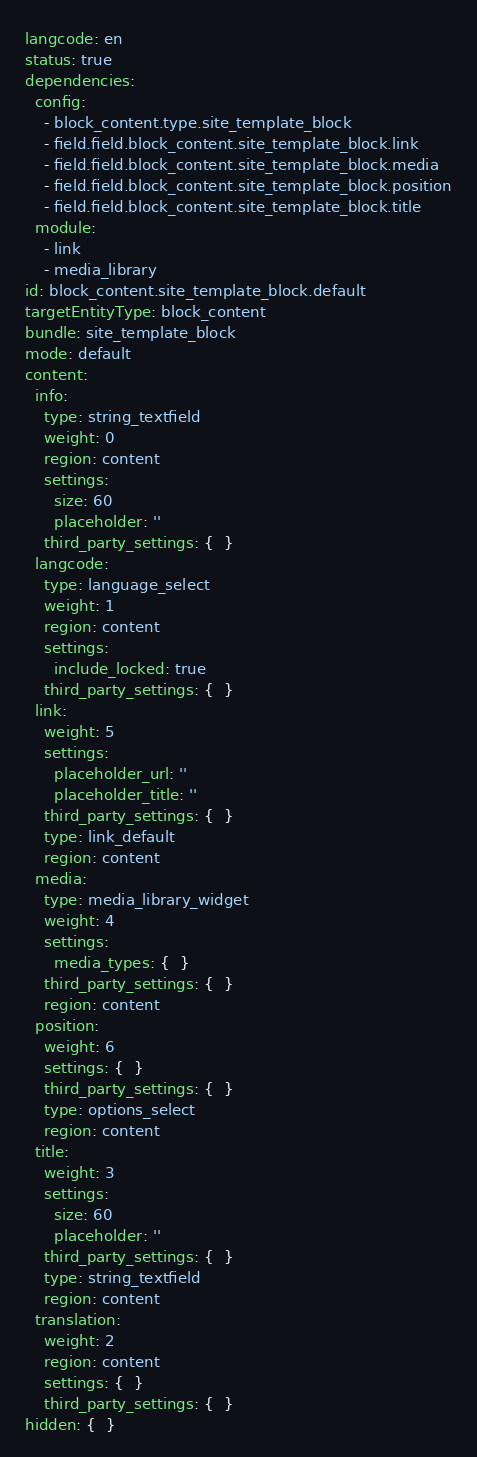Convert code to text. <code><loc_0><loc_0><loc_500><loc_500><_YAML_>langcode: en
status: true
dependencies:
  config:
    - block_content.type.site_template_block
    - field.field.block_content.site_template_block.link
    - field.field.block_content.site_template_block.media
    - field.field.block_content.site_template_block.position
    - field.field.block_content.site_template_block.title
  module:
    - link
    - media_library
id: block_content.site_template_block.default
targetEntityType: block_content
bundle: site_template_block
mode: default
content:
  info:
    type: string_textfield
    weight: 0
    region: content
    settings:
      size: 60
      placeholder: ''
    third_party_settings: {  }
  langcode:
    type: language_select
    weight: 1
    region: content
    settings:
      include_locked: true
    third_party_settings: {  }
  link:
    weight: 5
    settings:
      placeholder_url: ''
      placeholder_title: ''
    third_party_settings: {  }
    type: link_default
    region: content
  media:
    type: media_library_widget
    weight: 4
    settings:
      media_types: {  }
    third_party_settings: {  }
    region: content
  position:
    weight: 6
    settings: {  }
    third_party_settings: {  }
    type: options_select
    region: content
  title:
    weight: 3
    settings:
      size: 60
      placeholder: ''
    third_party_settings: {  }
    type: string_textfield
    region: content
  translation:
    weight: 2
    region: content
    settings: {  }
    third_party_settings: {  }
hidden: {  }
</code> 